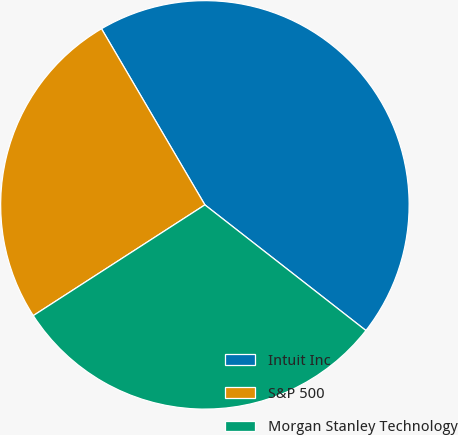<chart> <loc_0><loc_0><loc_500><loc_500><pie_chart><fcel>Intuit Inc<fcel>S&P 500<fcel>Morgan Stanley Technology<nl><fcel>43.99%<fcel>25.67%<fcel>30.33%<nl></chart> 